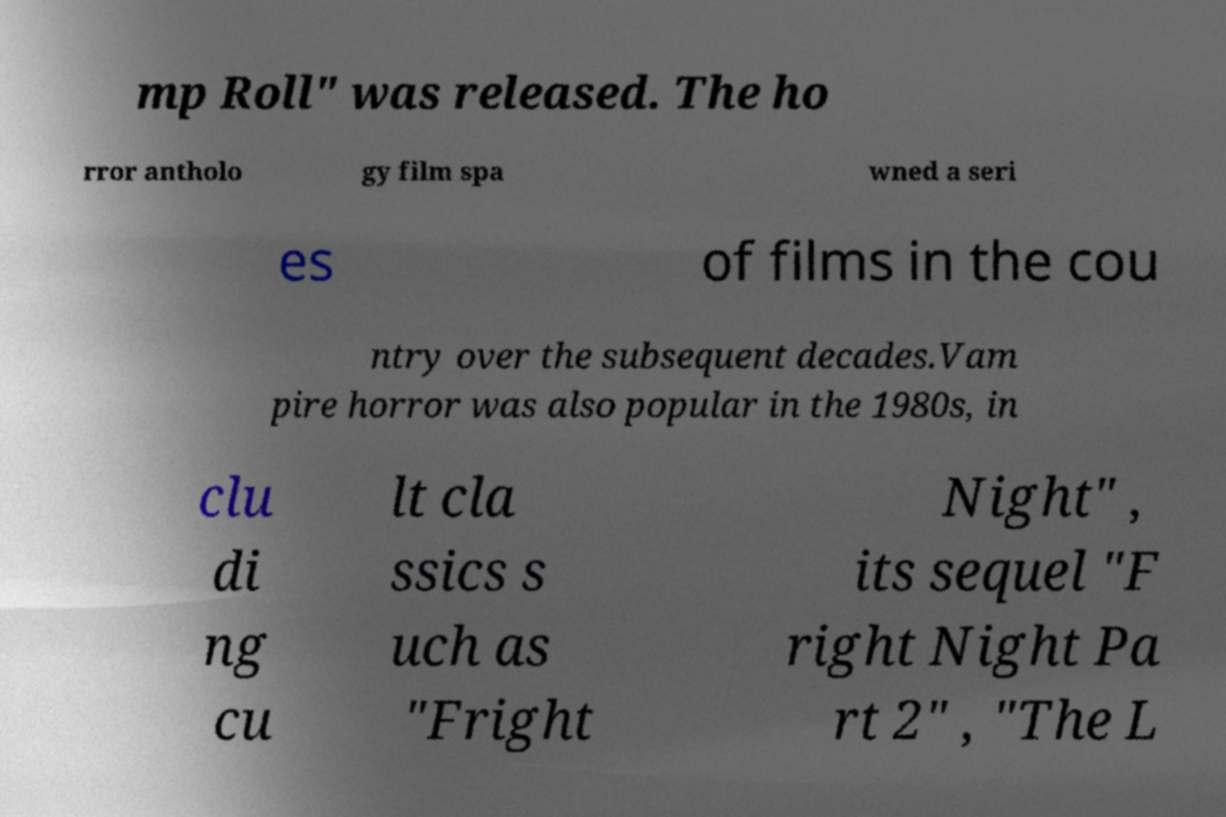Please read and relay the text visible in this image. What does it say? mp Roll" was released. The ho rror antholo gy film spa wned a seri es of films in the cou ntry over the subsequent decades.Vam pire horror was also popular in the 1980s, in clu di ng cu lt cla ssics s uch as "Fright Night" , its sequel "F right Night Pa rt 2" , "The L 